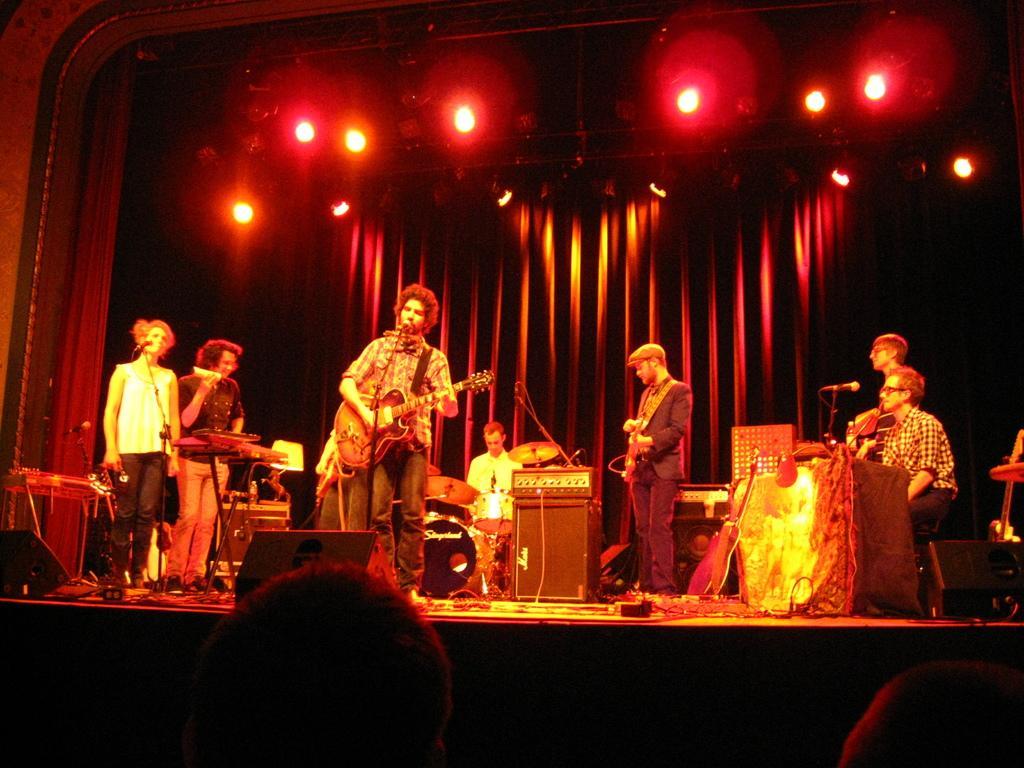How would you summarize this image in a sentence or two? As we can see in the image there are few people standing on stage and playing different types of musical instruments. 